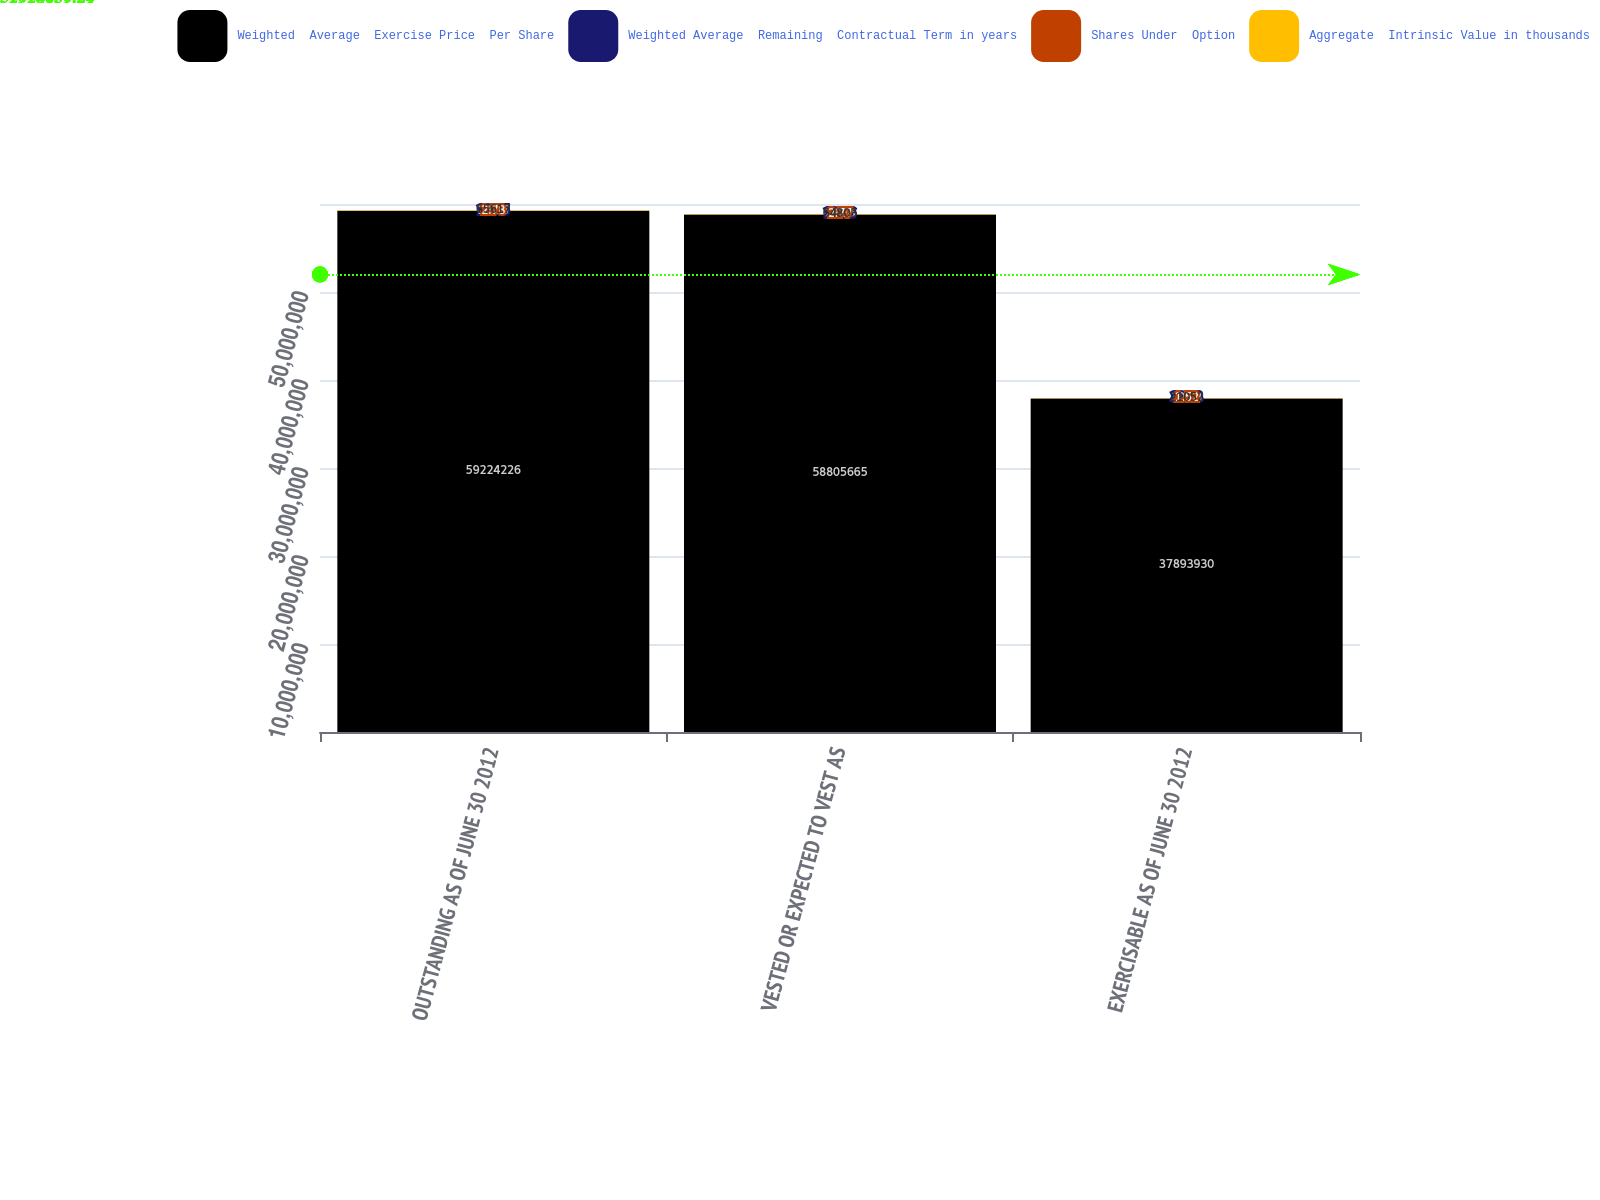<chart> <loc_0><loc_0><loc_500><loc_500><stacked_bar_chart><ecel><fcel>OUTSTANDING AS OF JUNE 30 2012<fcel>VESTED OR EXPECTED TO VEST AS<fcel>EXERCISABLE AS OF JUNE 30 2012<nl><fcel>Weighted  Average  Exercise Price  Per Share<fcel>5.92242e+07<fcel>5.88057e+07<fcel>3.78939e+07<nl><fcel>Weighted Average  Remaining  Contractual Term in years<fcel>29.85<fcel>29.86<fcel>30.93<nl><fcel>Shares Under  Option<fcel>2.78<fcel>2.77<fcel>1.52<nl><fcel>Aggregate  Intrinsic Value in thousands<fcel>65617<fcel>64803<fcel>21052<nl></chart> 